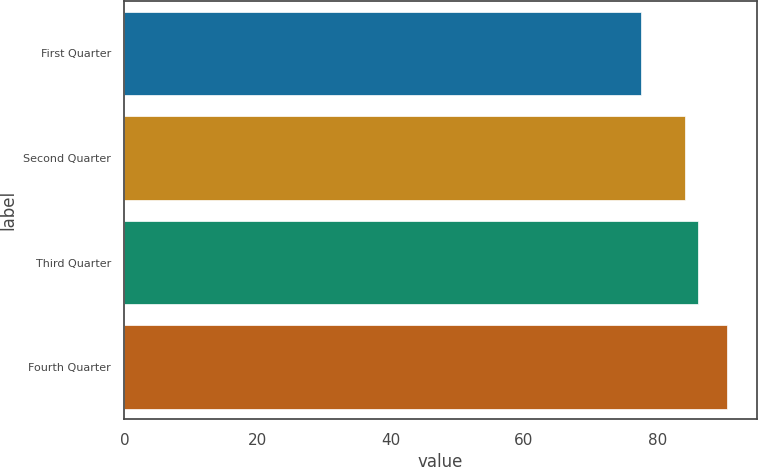Convert chart. <chart><loc_0><loc_0><loc_500><loc_500><bar_chart><fcel>First Quarter<fcel>Second Quarter<fcel>Third Quarter<fcel>Fourth Quarter<nl><fcel>77.52<fcel>84.15<fcel>86.15<fcel>90.46<nl></chart> 